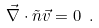Convert formula to latex. <formula><loc_0><loc_0><loc_500><loc_500>\vec { \nabla } \cdot \tilde { n } \vec { v } = 0 \ .</formula> 